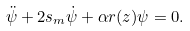Convert formula to latex. <formula><loc_0><loc_0><loc_500><loc_500>\ddot { \psi } + 2 s _ { m } \dot { \psi } + \alpha r ( z ) \psi = 0 .</formula> 